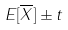<formula> <loc_0><loc_0><loc_500><loc_500>E [ \overline { X } ] \pm t</formula> 